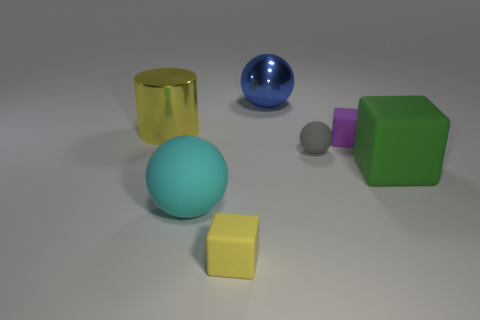Is there any other thing of the same color as the large metallic cylinder?
Offer a terse response. Yes. Do the rubber cube that is in front of the green cube and the metal cylinder have the same color?
Your response must be concise. Yes. There is a rubber sphere that is the same size as the cylinder; what is its color?
Provide a short and direct response. Cyan. What is the large ball behind the big cube made of?
Provide a short and direct response. Metal. What material is the large object that is both behind the small gray ball and on the right side of the large yellow object?
Make the answer very short. Metal. There is a thing to the right of the purple rubber thing; is its size the same as the blue thing?
Give a very brief answer. Yes. What shape is the tiny gray object?
Give a very brief answer. Sphere. How many yellow matte things have the same shape as the green rubber thing?
Offer a terse response. 1. How many small matte blocks are behind the cyan rubber ball and in front of the green matte block?
Your answer should be compact. 0. The shiny cylinder has what color?
Your answer should be very brief. Yellow. 